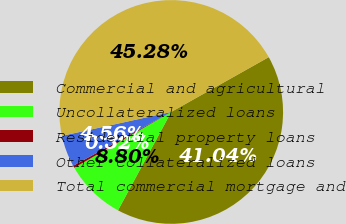<chart> <loc_0><loc_0><loc_500><loc_500><pie_chart><fcel>Commercial and agricultural<fcel>Uncollateralized loans<fcel>Residential property loans<fcel>Other collateralized loans<fcel>Total commercial mortgage and<nl><fcel>41.05%<fcel>8.8%<fcel>0.32%<fcel>4.56%<fcel>45.29%<nl></chart> 